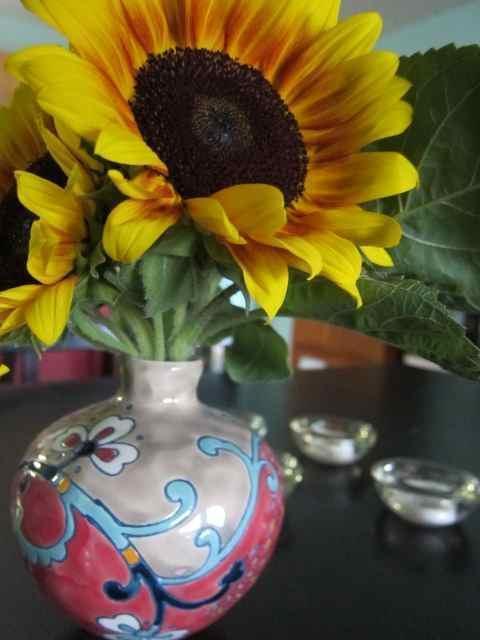How many bowls are there?
Give a very brief answer. 2. 